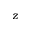Convert formula to latex. <formula><loc_0><loc_0><loc_500><loc_500>{ z }</formula> 